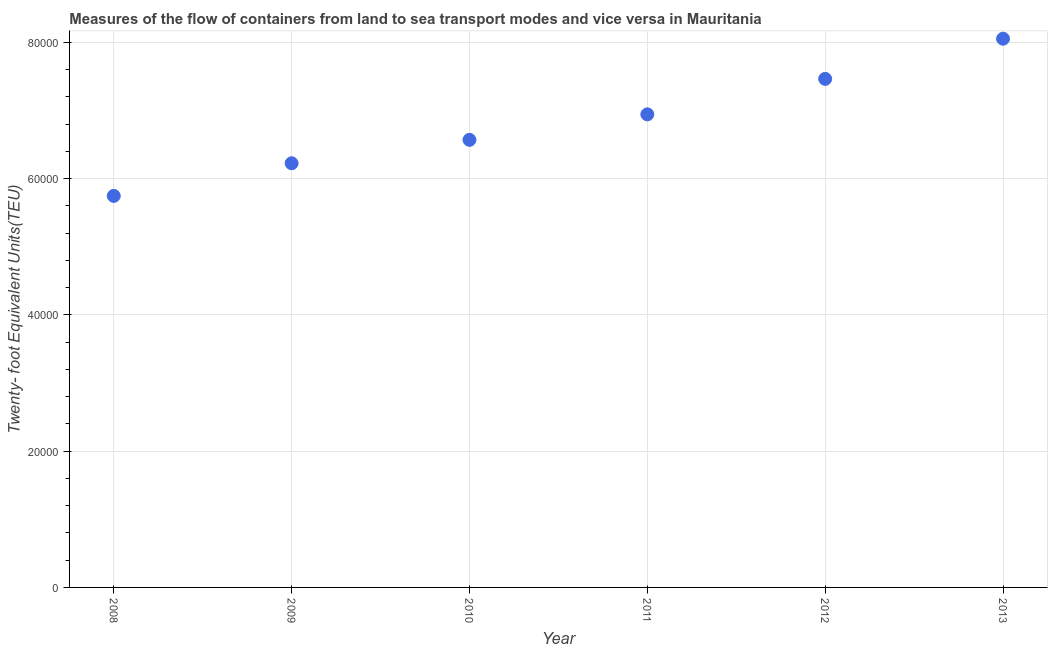What is the container port traffic in 2009?
Make the answer very short. 6.23e+04. Across all years, what is the maximum container port traffic?
Provide a short and direct response. 8.06e+04. Across all years, what is the minimum container port traffic?
Provide a succinct answer. 5.75e+04. In which year was the container port traffic maximum?
Provide a succinct answer. 2013. In which year was the container port traffic minimum?
Keep it short and to the point. 2008. What is the sum of the container port traffic?
Your answer should be compact. 4.10e+05. What is the difference between the container port traffic in 2012 and 2013?
Ensure brevity in your answer.  -5898.06. What is the average container port traffic per year?
Offer a terse response. 6.84e+04. What is the median container port traffic?
Offer a terse response. 6.76e+04. Do a majority of the years between 2013 and 2008 (inclusive) have container port traffic greater than 44000 TEU?
Keep it short and to the point. Yes. What is the ratio of the container port traffic in 2008 to that in 2011?
Offer a very short reply. 0.83. Is the difference between the container port traffic in 2008 and 2009 greater than the difference between any two years?
Offer a very short reply. No. What is the difference between the highest and the second highest container port traffic?
Your answer should be very brief. 5898.06. Is the sum of the container port traffic in 2009 and 2010 greater than the maximum container port traffic across all years?
Provide a short and direct response. Yes. What is the difference between the highest and the lowest container port traffic?
Provide a succinct answer. 2.31e+04. In how many years, is the container port traffic greater than the average container port traffic taken over all years?
Ensure brevity in your answer.  3. Does the container port traffic monotonically increase over the years?
Your response must be concise. Yes. How many dotlines are there?
Offer a terse response. 1. What is the difference between two consecutive major ticks on the Y-axis?
Provide a short and direct response. 2.00e+04. Are the values on the major ticks of Y-axis written in scientific E-notation?
Your answer should be very brief. No. Does the graph contain any zero values?
Give a very brief answer. No. What is the title of the graph?
Ensure brevity in your answer.  Measures of the flow of containers from land to sea transport modes and vice versa in Mauritania. What is the label or title of the X-axis?
Keep it short and to the point. Year. What is the label or title of the Y-axis?
Make the answer very short. Twenty- foot Equivalent Units(TEU). What is the Twenty- foot Equivalent Units(TEU) in 2008?
Keep it short and to the point. 5.75e+04. What is the Twenty- foot Equivalent Units(TEU) in 2009?
Your answer should be compact. 6.23e+04. What is the Twenty- foot Equivalent Units(TEU) in 2010?
Provide a succinct answer. 6.57e+04. What is the Twenty- foot Equivalent Units(TEU) in 2011?
Offer a very short reply. 6.95e+04. What is the Twenty- foot Equivalent Units(TEU) in 2012?
Offer a terse response. 7.47e+04. What is the Twenty- foot Equivalent Units(TEU) in 2013?
Keep it short and to the point. 8.06e+04. What is the difference between the Twenty- foot Equivalent Units(TEU) in 2008 and 2009?
Offer a terse response. -4791. What is the difference between the Twenty- foot Equivalent Units(TEU) in 2008 and 2010?
Provide a short and direct response. -8227. What is the difference between the Twenty- foot Equivalent Units(TEU) in 2008 and 2011?
Keep it short and to the point. -1.20e+04. What is the difference between the Twenty- foot Equivalent Units(TEU) in 2008 and 2012?
Offer a very short reply. -1.72e+04. What is the difference between the Twenty- foot Equivalent Units(TEU) in 2008 and 2013?
Your answer should be very brief. -2.31e+04. What is the difference between the Twenty- foot Equivalent Units(TEU) in 2009 and 2010?
Offer a very short reply. -3436. What is the difference between the Twenty- foot Equivalent Units(TEU) in 2009 and 2011?
Provide a succinct answer. -7181.19. What is the difference between the Twenty- foot Equivalent Units(TEU) in 2009 and 2012?
Your answer should be very brief. -1.24e+04. What is the difference between the Twenty- foot Equivalent Units(TEU) in 2009 and 2013?
Offer a very short reply. -1.83e+04. What is the difference between the Twenty- foot Equivalent Units(TEU) in 2010 and 2011?
Keep it short and to the point. -3745.18. What is the difference between the Twenty- foot Equivalent Units(TEU) in 2010 and 2012?
Your response must be concise. -8953.95. What is the difference between the Twenty- foot Equivalent Units(TEU) in 2010 and 2013?
Offer a very short reply. -1.49e+04. What is the difference between the Twenty- foot Equivalent Units(TEU) in 2011 and 2012?
Your response must be concise. -5208.76. What is the difference between the Twenty- foot Equivalent Units(TEU) in 2011 and 2013?
Offer a terse response. -1.11e+04. What is the difference between the Twenty- foot Equivalent Units(TEU) in 2012 and 2013?
Your answer should be very brief. -5898.06. What is the ratio of the Twenty- foot Equivalent Units(TEU) in 2008 to that in 2009?
Your answer should be compact. 0.92. What is the ratio of the Twenty- foot Equivalent Units(TEU) in 2008 to that in 2011?
Offer a terse response. 0.83. What is the ratio of the Twenty- foot Equivalent Units(TEU) in 2008 to that in 2012?
Offer a very short reply. 0.77. What is the ratio of the Twenty- foot Equivalent Units(TEU) in 2008 to that in 2013?
Give a very brief answer. 0.71. What is the ratio of the Twenty- foot Equivalent Units(TEU) in 2009 to that in 2010?
Your answer should be very brief. 0.95. What is the ratio of the Twenty- foot Equivalent Units(TEU) in 2009 to that in 2011?
Offer a very short reply. 0.9. What is the ratio of the Twenty- foot Equivalent Units(TEU) in 2009 to that in 2012?
Your answer should be very brief. 0.83. What is the ratio of the Twenty- foot Equivalent Units(TEU) in 2009 to that in 2013?
Provide a short and direct response. 0.77. What is the ratio of the Twenty- foot Equivalent Units(TEU) in 2010 to that in 2011?
Provide a succinct answer. 0.95. What is the ratio of the Twenty- foot Equivalent Units(TEU) in 2010 to that in 2013?
Your answer should be compact. 0.82. What is the ratio of the Twenty- foot Equivalent Units(TEU) in 2011 to that in 2012?
Your answer should be very brief. 0.93. What is the ratio of the Twenty- foot Equivalent Units(TEU) in 2011 to that in 2013?
Your answer should be compact. 0.86. What is the ratio of the Twenty- foot Equivalent Units(TEU) in 2012 to that in 2013?
Provide a short and direct response. 0.93. 